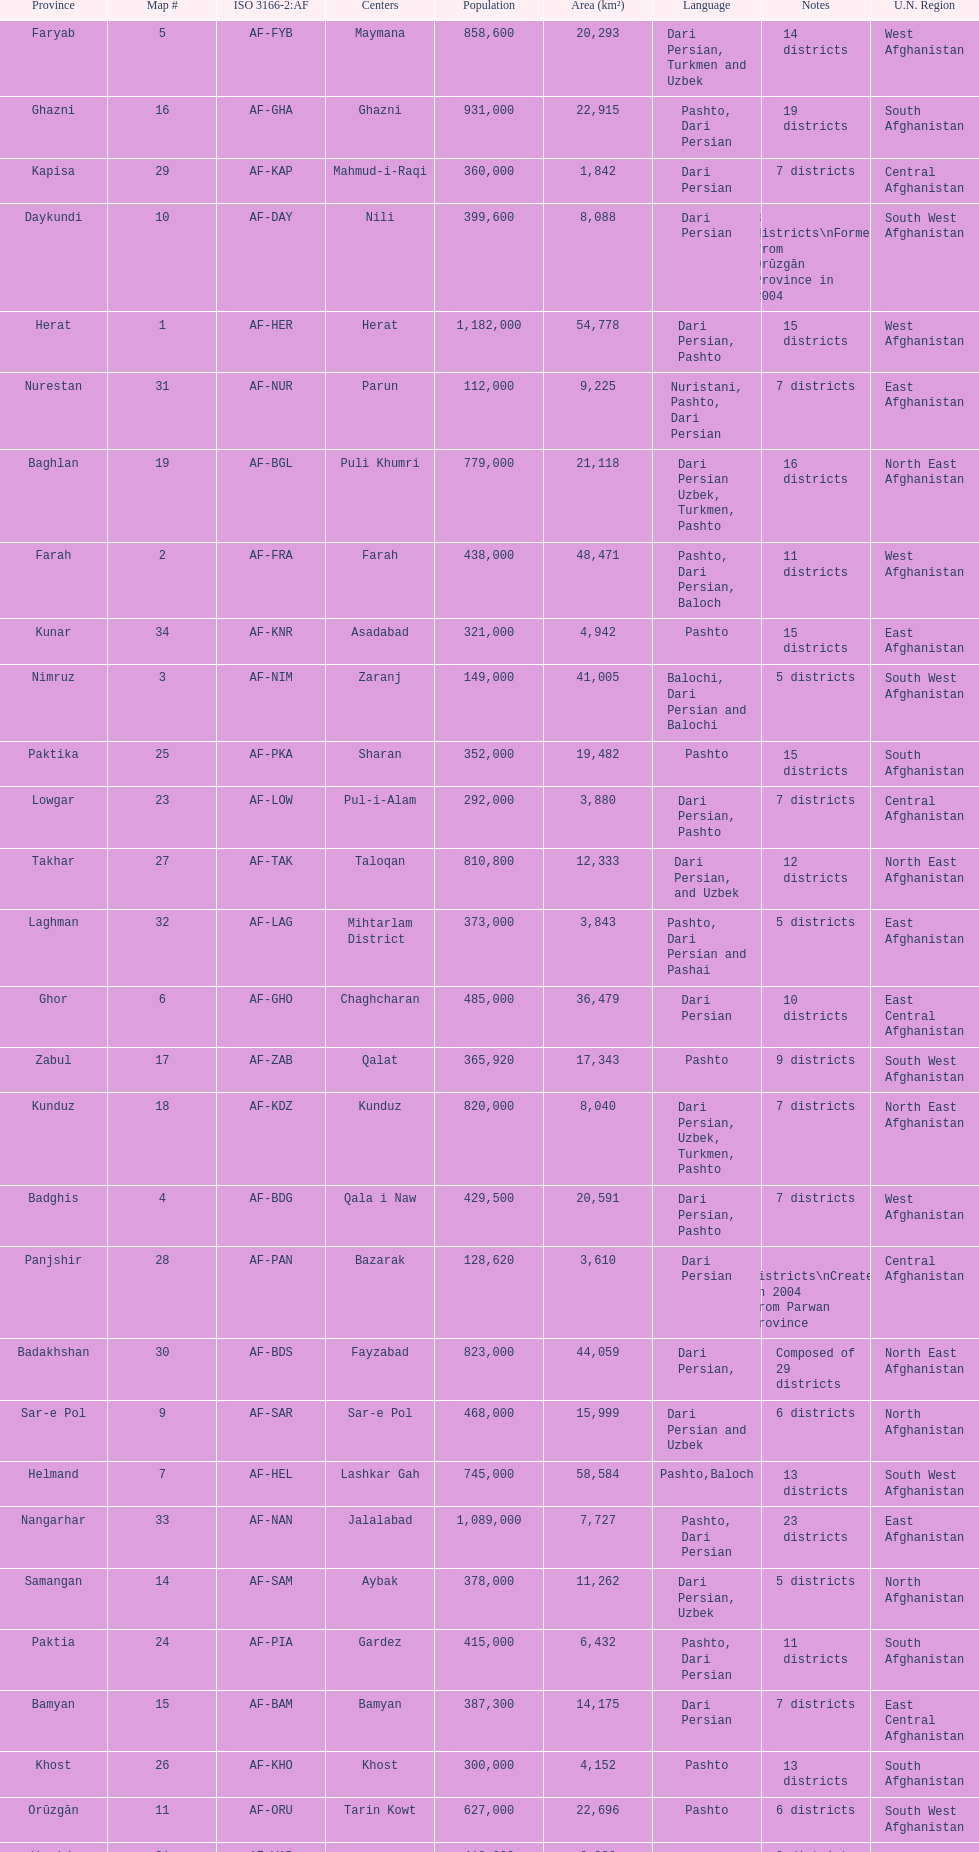How many districts are in the province of kunduz? 7. 